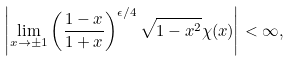Convert formula to latex. <formula><loc_0><loc_0><loc_500><loc_500>\left | \lim _ { x \to \pm 1 } \left ( \frac { 1 - x } { 1 + x } \right ) ^ { \epsilon / 4 } \sqrt { 1 - x ^ { 2 } } \chi ( x ) \right | < \infty ,</formula> 